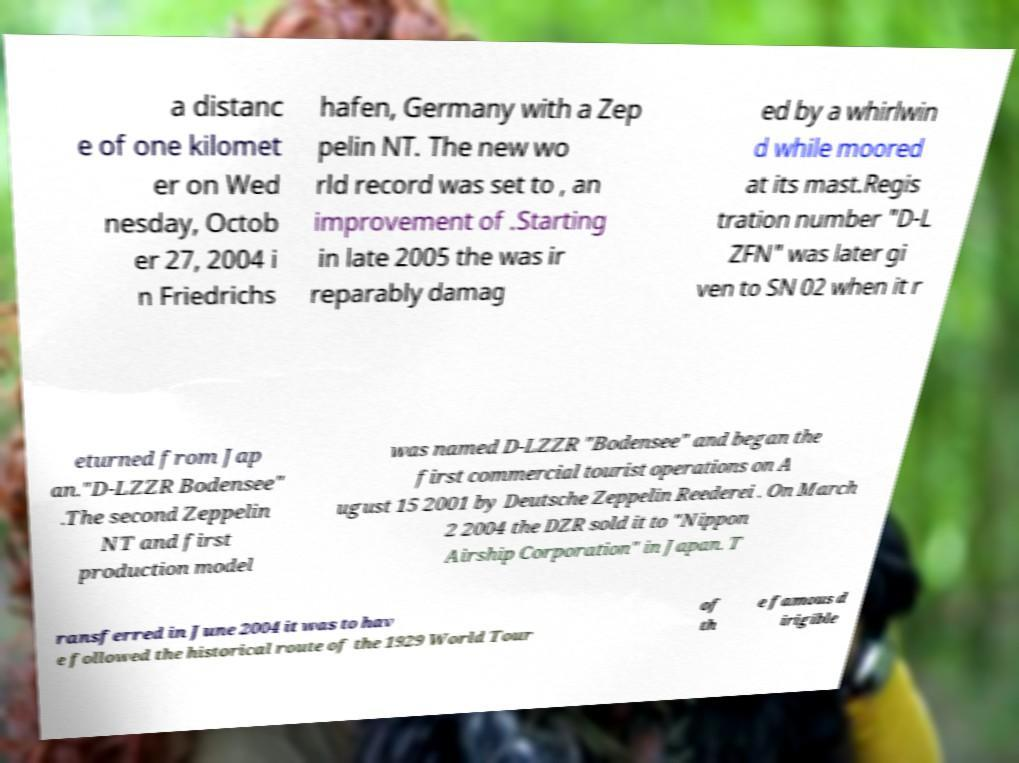Could you extract and type out the text from this image? a distanc e of one kilomet er on Wed nesday, Octob er 27, 2004 i n Friedrichs hafen, Germany with a Zep pelin NT. The new wo rld record was set to , an improvement of .Starting in late 2005 the was ir reparably damag ed by a whirlwin d while moored at its mast.Regis tration number "D-L ZFN" was later gi ven to SN 02 when it r eturned from Jap an."D-LZZR Bodensee" .The second Zeppelin NT and first production model was named D-LZZR "Bodensee" and began the first commercial tourist operations on A ugust 15 2001 by Deutsche Zeppelin Reederei . On March 2 2004 the DZR sold it to "Nippon Airship Corporation" in Japan. T ransferred in June 2004 it was to hav e followed the historical route of the 1929 World Tour of th e famous d irigible 